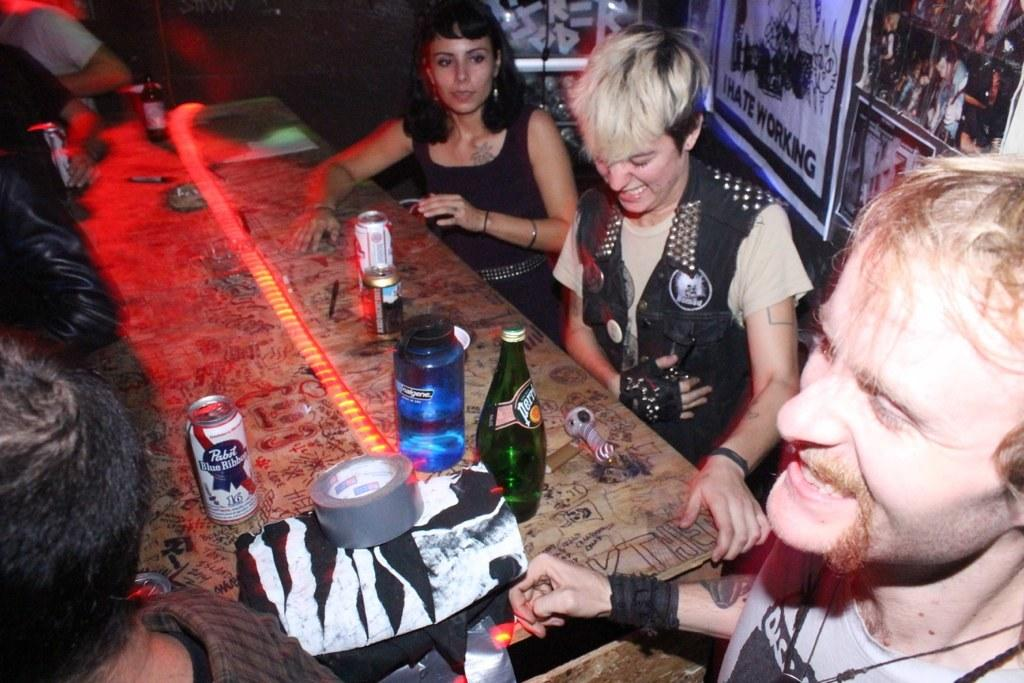Who or what is present in the image? There are people in the image. What is the primary object in the image? There is a table in the image. What items can be seen on the table? There are bottles, cans, tape, and other items on the table. What is on the wall in the image? There are posters on the wall. Can you see a key hanging from the wall in the image? There is no key visible on the wall in the image. 